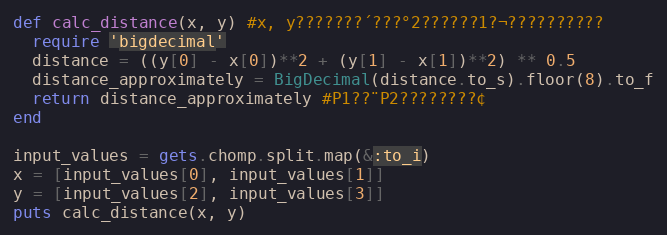Convert code to text. <code><loc_0><loc_0><loc_500><loc_500><_Ruby_>def calc_distance(x, y) #x, y???????´???°2??????1?¬??????????
  require 'bigdecimal'
  distance = ((y[0] - x[0])**2 + (y[1] - x[1])**2) ** 0.5
  distance_approximately = BigDecimal(distance.to_s).floor(8).to_f
  return distance_approximately #P1??¨P2????????¢
end

input_values = gets.chomp.split.map(&:to_i)
x = [input_values[0], input_values[1]]
y = [input_values[2], input_values[3]]
puts calc_distance(x, y)</code> 